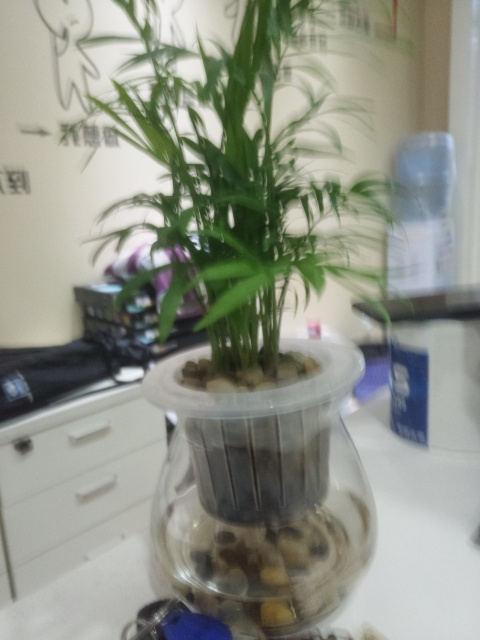Describe the condition of the plant and the potential care it requires. Despite the blurriness of the image, the plant appears to be in good health, with vibrant green leaves. Care for such a plant typically includes ensuring it receives adequate indirect light, maintaining an optimal water level in the hydroponic system, and periodic fertilizing for nutrients. 